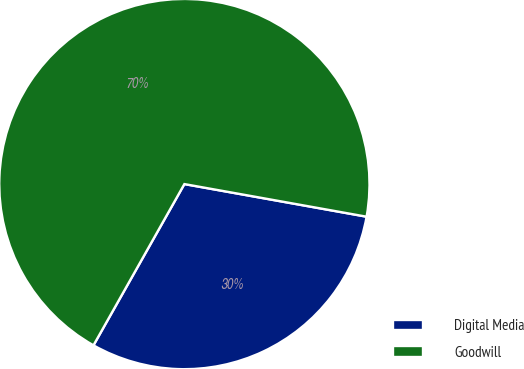<chart> <loc_0><loc_0><loc_500><loc_500><pie_chart><fcel>Digital Media<fcel>Goodwill<nl><fcel>30.35%<fcel>69.65%<nl></chart> 